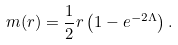<formula> <loc_0><loc_0><loc_500><loc_500>m ( r ) = \frac { 1 } { 2 } r \left ( 1 - e ^ { - 2 \Lambda } \right ) .</formula> 